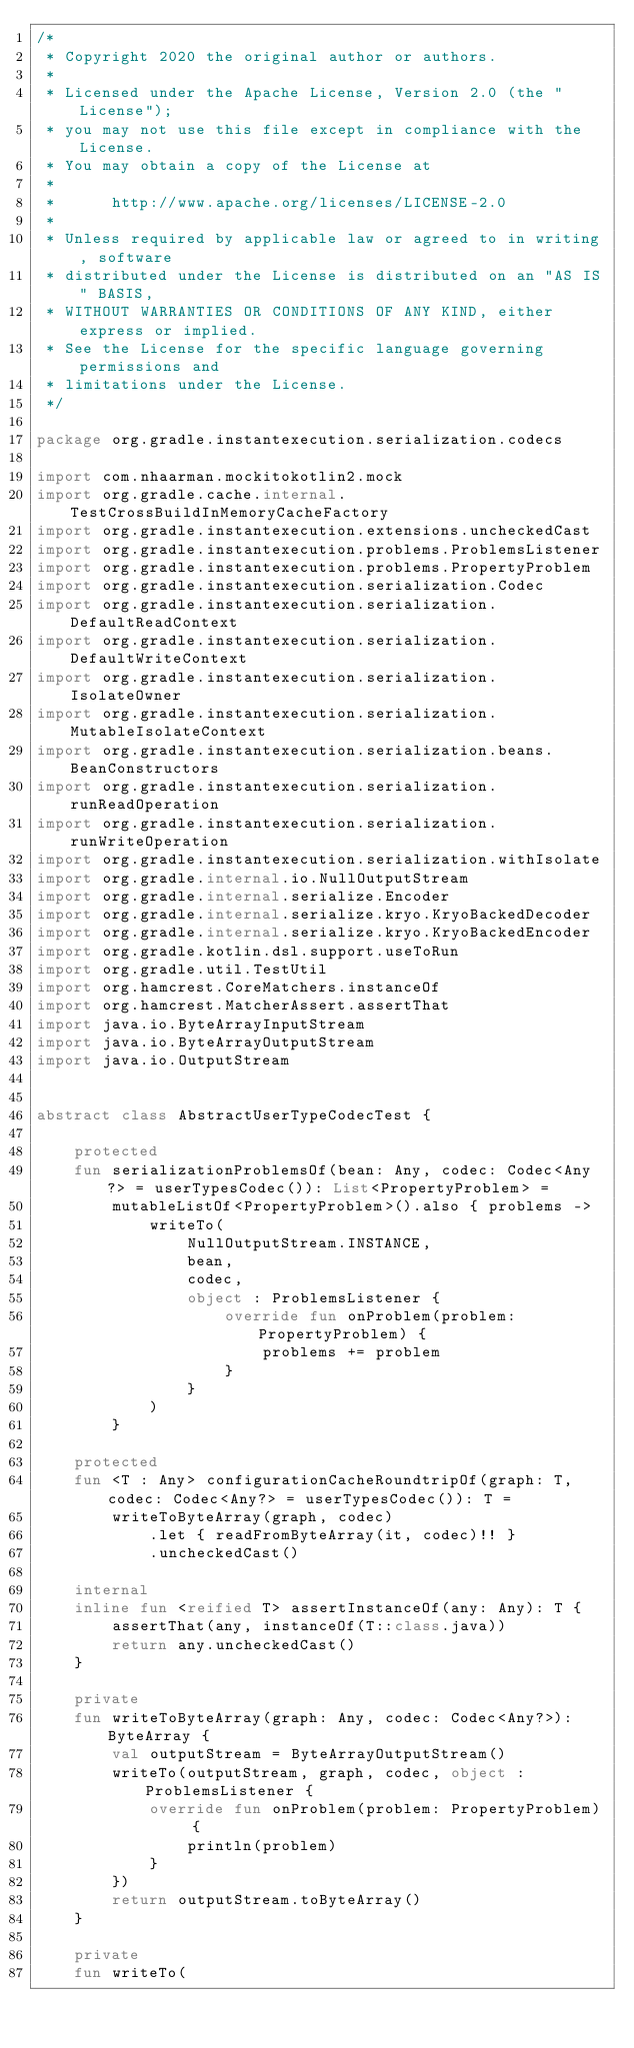<code> <loc_0><loc_0><loc_500><loc_500><_Kotlin_>/*
 * Copyright 2020 the original author or authors.
 *
 * Licensed under the Apache License, Version 2.0 (the "License");
 * you may not use this file except in compliance with the License.
 * You may obtain a copy of the License at
 *
 *      http://www.apache.org/licenses/LICENSE-2.0
 *
 * Unless required by applicable law or agreed to in writing, software
 * distributed under the License is distributed on an "AS IS" BASIS,
 * WITHOUT WARRANTIES OR CONDITIONS OF ANY KIND, either express or implied.
 * See the License for the specific language governing permissions and
 * limitations under the License.
 */

package org.gradle.instantexecution.serialization.codecs

import com.nhaarman.mockitokotlin2.mock
import org.gradle.cache.internal.TestCrossBuildInMemoryCacheFactory
import org.gradle.instantexecution.extensions.uncheckedCast
import org.gradle.instantexecution.problems.ProblemsListener
import org.gradle.instantexecution.problems.PropertyProblem
import org.gradle.instantexecution.serialization.Codec
import org.gradle.instantexecution.serialization.DefaultReadContext
import org.gradle.instantexecution.serialization.DefaultWriteContext
import org.gradle.instantexecution.serialization.IsolateOwner
import org.gradle.instantexecution.serialization.MutableIsolateContext
import org.gradle.instantexecution.serialization.beans.BeanConstructors
import org.gradle.instantexecution.serialization.runReadOperation
import org.gradle.instantexecution.serialization.runWriteOperation
import org.gradle.instantexecution.serialization.withIsolate
import org.gradle.internal.io.NullOutputStream
import org.gradle.internal.serialize.Encoder
import org.gradle.internal.serialize.kryo.KryoBackedDecoder
import org.gradle.internal.serialize.kryo.KryoBackedEncoder
import org.gradle.kotlin.dsl.support.useToRun
import org.gradle.util.TestUtil
import org.hamcrest.CoreMatchers.instanceOf
import org.hamcrest.MatcherAssert.assertThat
import java.io.ByteArrayInputStream
import java.io.ByteArrayOutputStream
import java.io.OutputStream


abstract class AbstractUserTypeCodecTest {

    protected
    fun serializationProblemsOf(bean: Any, codec: Codec<Any?> = userTypesCodec()): List<PropertyProblem> =
        mutableListOf<PropertyProblem>().also { problems ->
            writeTo(
                NullOutputStream.INSTANCE,
                bean,
                codec,
                object : ProblemsListener {
                    override fun onProblem(problem: PropertyProblem) {
                        problems += problem
                    }
                }
            )
        }

    protected
    fun <T : Any> configurationCacheRoundtripOf(graph: T, codec: Codec<Any?> = userTypesCodec()): T =
        writeToByteArray(graph, codec)
            .let { readFromByteArray(it, codec)!! }
            .uncheckedCast()

    internal
    inline fun <reified T> assertInstanceOf(any: Any): T {
        assertThat(any, instanceOf(T::class.java))
        return any.uncheckedCast()
    }

    private
    fun writeToByteArray(graph: Any, codec: Codec<Any?>): ByteArray {
        val outputStream = ByteArrayOutputStream()
        writeTo(outputStream, graph, codec, object : ProblemsListener {
            override fun onProblem(problem: PropertyProblem) {
                println(problem)
            }
        })
        return outputStream.toByteArray()
    }

    private
    fun writeTo(</code> 